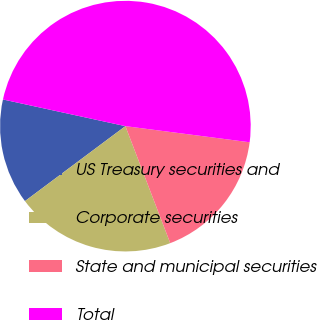<chart> <loc_0><loc_0><loc_500><loc_500><pie_chart><fcel>US Treasury securities and<fcel>Corporate securities<fcel>State and municipal securities<fcel>Total<nl><fcel>13.62%<fcel>20.62%<fcel>17.12%<fcel>48.64%<nl></chart> 